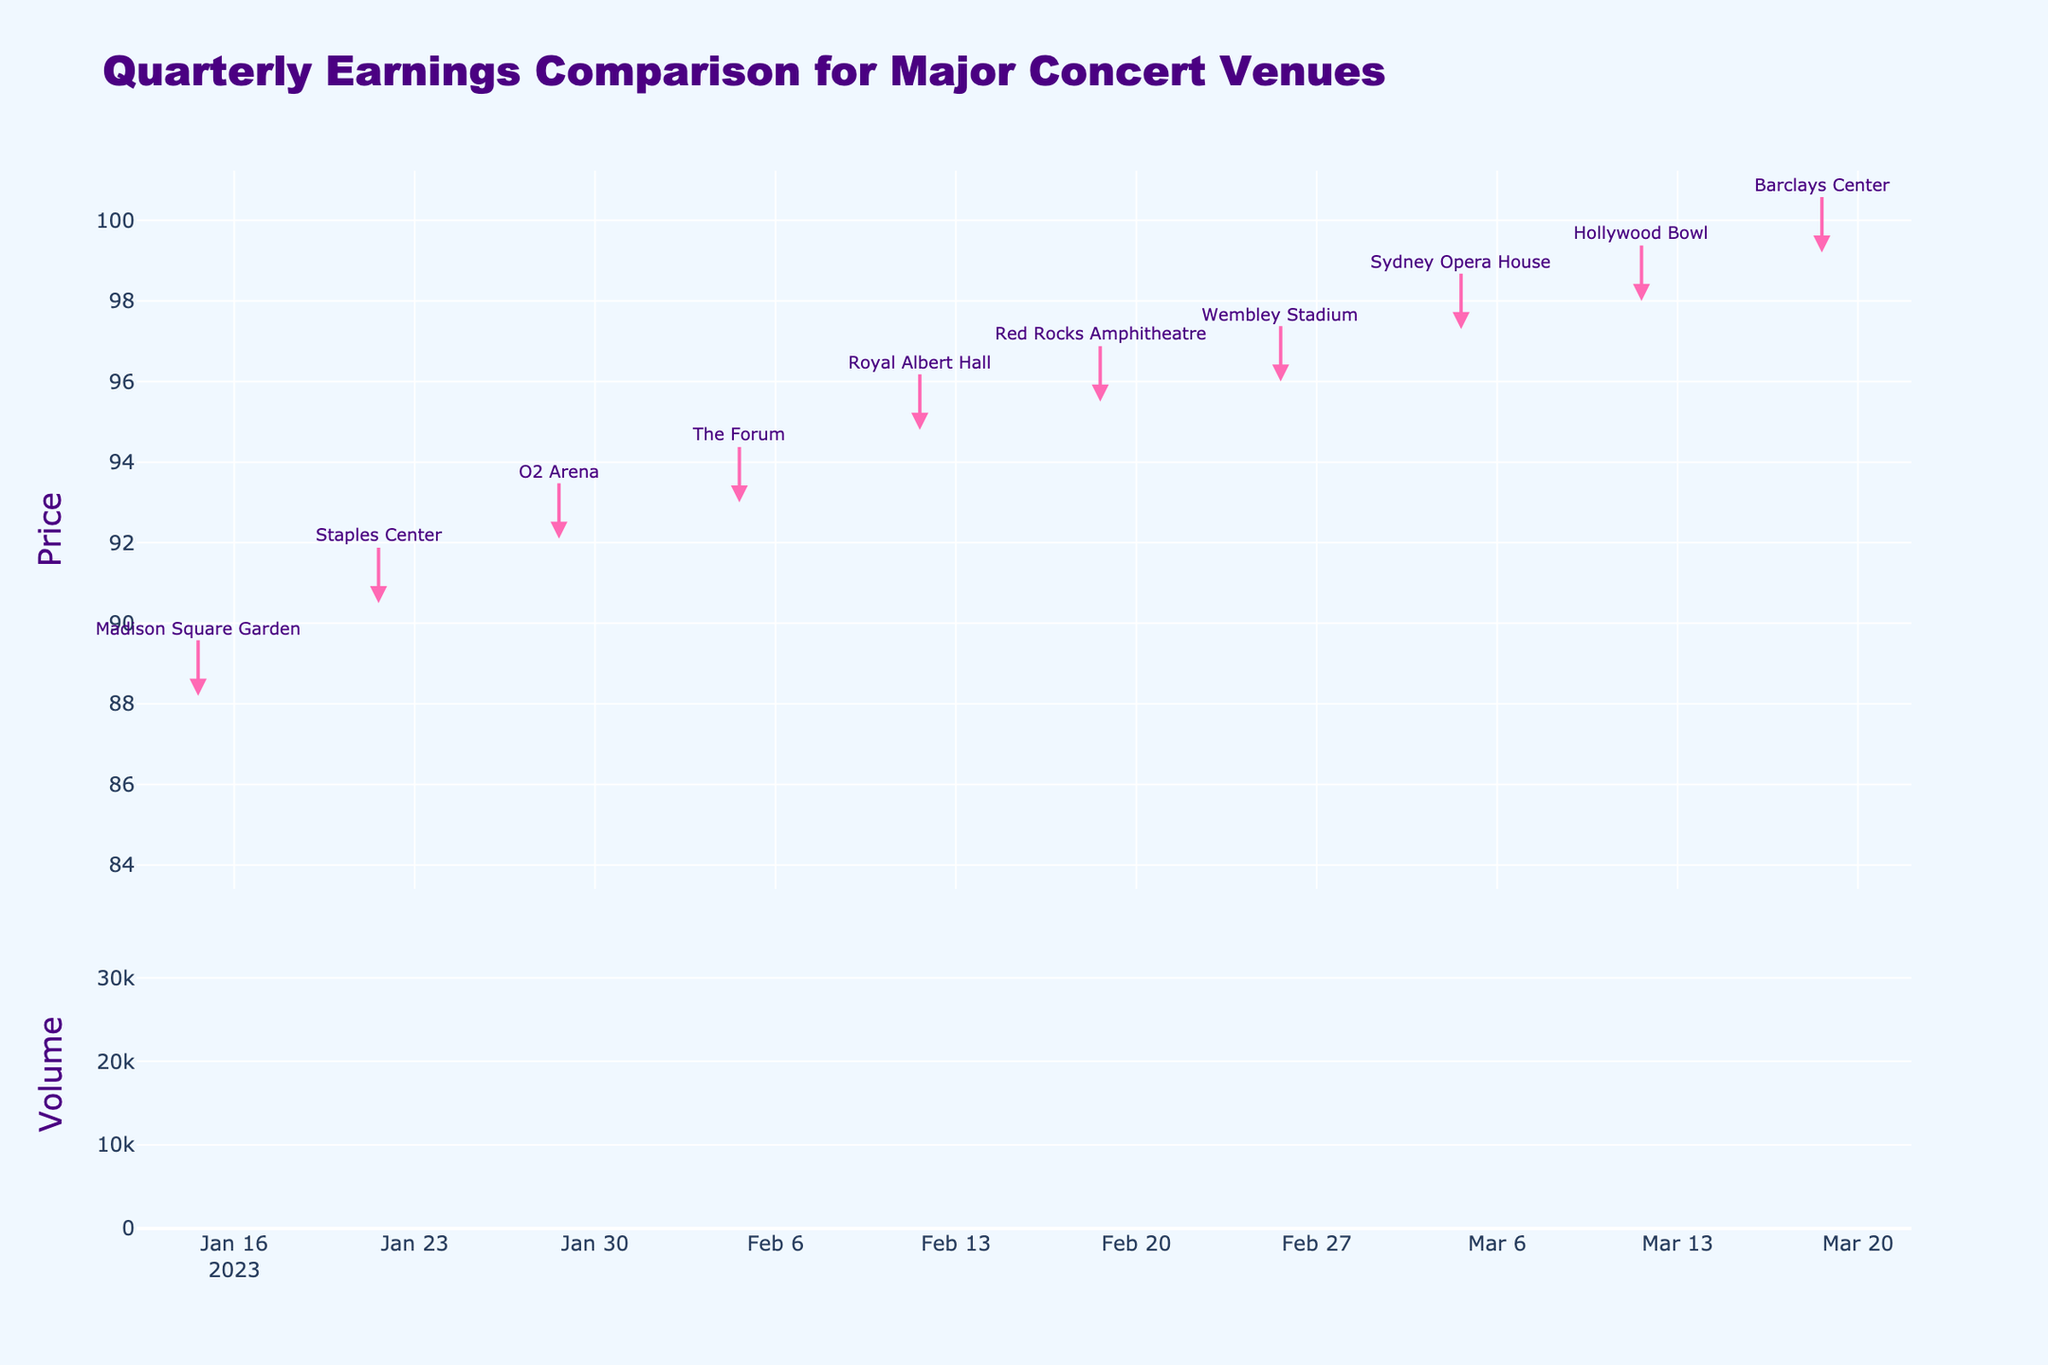How many data points are there in the figure? The figure has one data point per week, and there are data points from 2023-01-15 to 2023-03-19. Counting these, we have 10 data points in total
Answer: 10 What is the title of the figure? The title of the figure is clearly stated at the top of the plot.
Answer: Quarterly Earnings Comparison for Major Concert Venues What is the highest stock price recorded on the figure? The highest price can be observed from the top of the highest candlestick. The price reaches its maximum on 2023-03-12 at 98.0.
Answer: 98.0 Which week saw the highest trading volume? The volume bar chart at the bottom indicates the highest bar for the week of 2023-02-12.
Answer: 2023-02-12 What was the closing price on 2023-03-19? The closing price for that date can be read from the candlestick for 2023-03-19, which closes at 98.5.
Answer: 98.5 Compare the opening prices of the first and last weeks. Which is higher? The opening price on 2023-01-15 is 85.5 and it is 97.4 on 2023-03-19. Comparing these, the opening price on the last week (2023-03-19) is higher.
Answer: 2023-03-19 What is the average closing price for the data points shown in the figure? To find the average closing price, sum all closing prices (87.1 + 89.3 + 91.5 + 92.6 + 93.9 + 94.7 + 95.1 + 96.2 + 97.4 + 98.5) and divide by the number of data points (10). The calculation is 936.3 / 10 = 93.63.
Answer: 93.63 During which week did the stock price experience the largest range between high and low prices? The range for each week can be computed by subtracting the low from the high. The largest found difference is for the week 2023-03-12 (98.0 - 95.1 = 2.9).
Answer: 2023-03-12 What color indicates an increasing stock price in the candlestick chart? Observing the candlestick plot, the color used for increasing stock prices is hot pink.
Answer: hot pink Which concert venue corresponds to the highest closing price observed in the figure? An annotation at the highest closing price (98.5) on 2023-03-19 marks the venue as Barclays Center.
Answer: Barclays Center What is the general trend observed in the stock prices from January 15, 2023, to March 19, 2023? The general trend in the candlestick plot shows a noticeable upward progression from the initial to the final date.
Answer: Upward Trend 